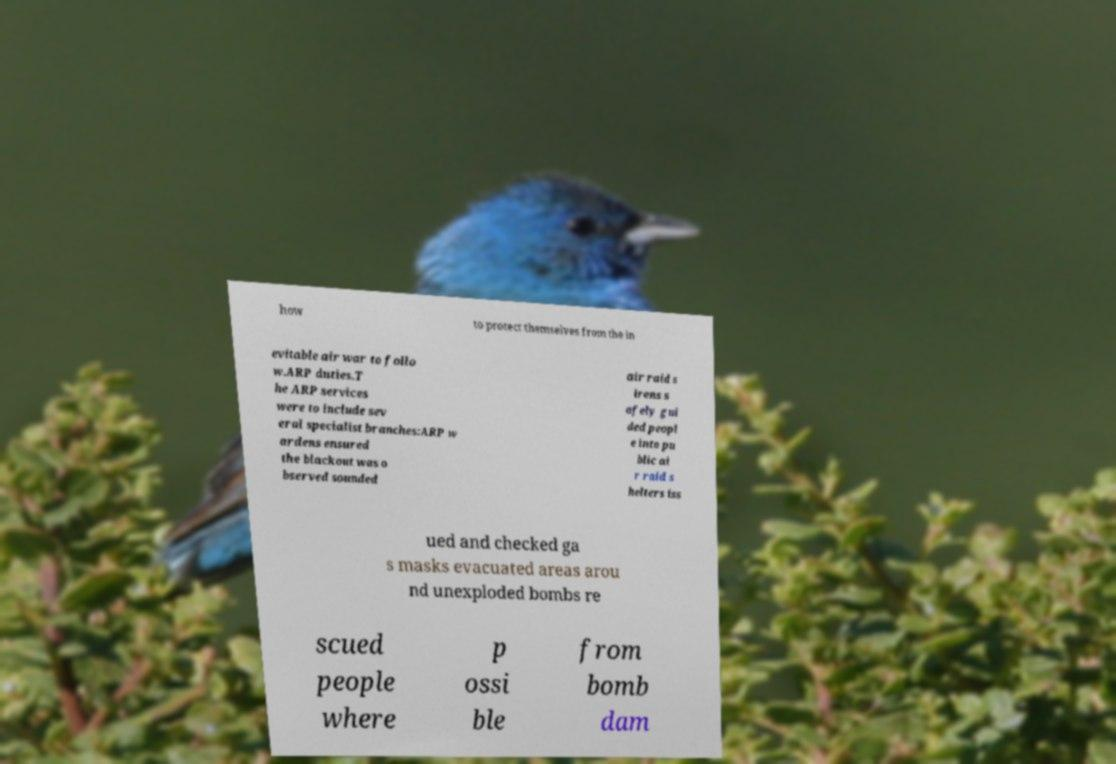For documentation purposes, I need the text within this image transcribed. Could you provide that? how to protect themselves from the in evitable air war to follo w.ARP duties.T he ARP services were to include sev eral specialist branches:ARP w ardens ensured the blackout was o bserved sounded air raid s irens s afely gui ded peopl e into pu blic ai r raid s helters iss ued and checked ga s masks evacuated areas arou nd unexploded bombs re scued people where p ossi ble from bomb dam 